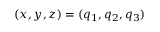Convert formula to latex. <formula><loc_0><loc_0><loc_500><loc_500>( x , y , z ) = ( q _ { 1 } , q _ { 2 } , q _ { 3 } )</formula> 